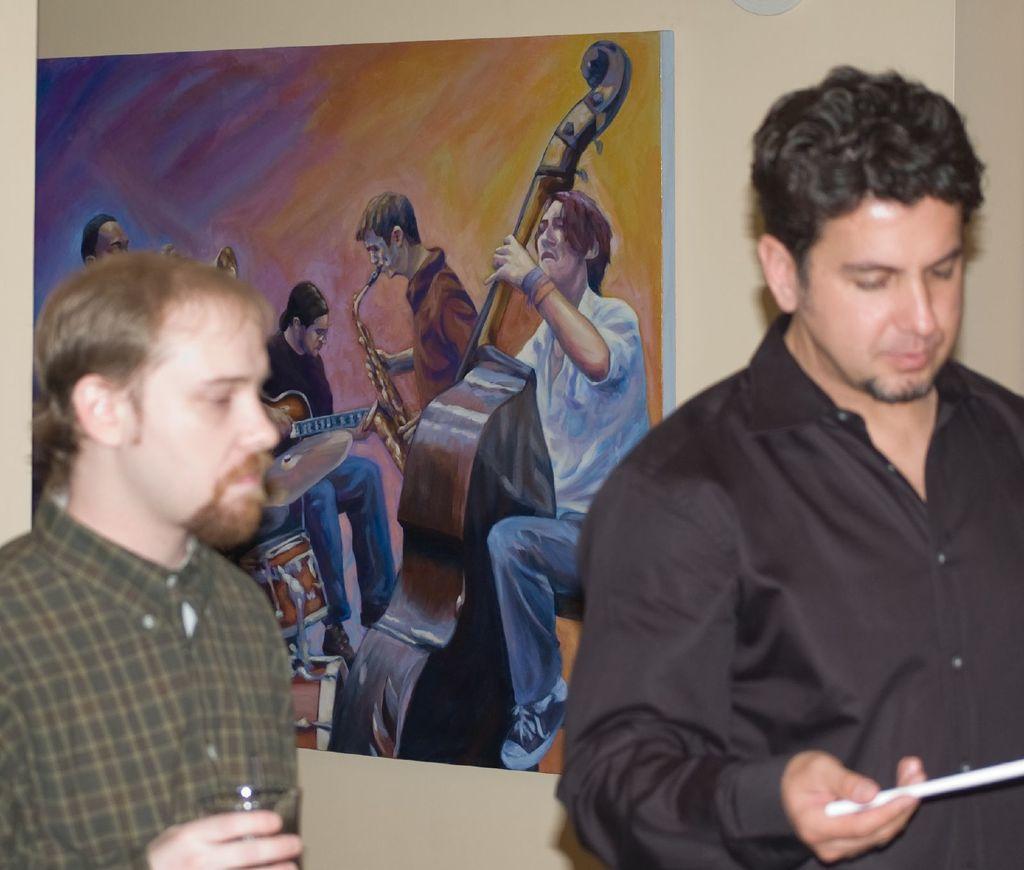Could you give a brief overview of what you see in this image? In this image we can see two men standing near the wall and holding objects. There is one object attached to the wall, one big painted poster attached to the wall and in this poster we can see some people playing musical instruments. 